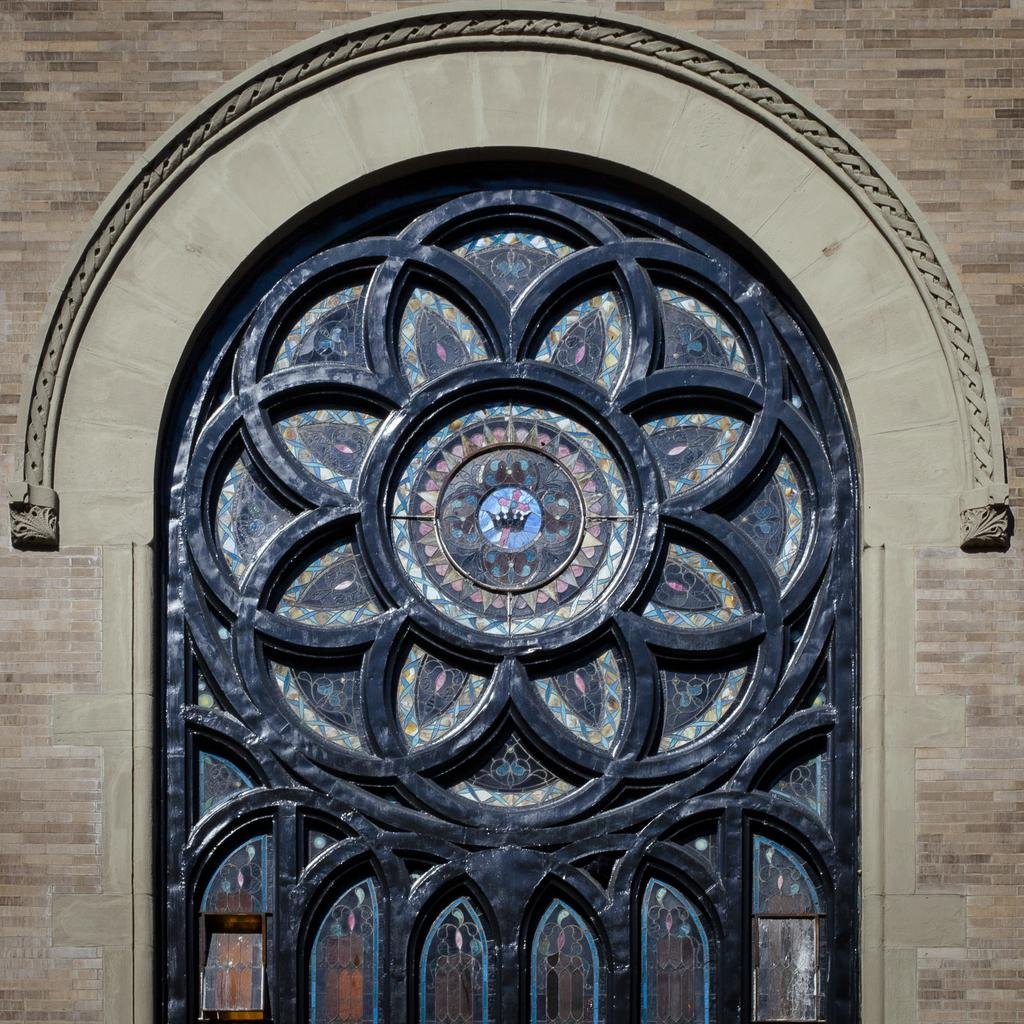What is present on the wall in the image? There is a wall in the image, and it has multiple glasses in the center and designs on it. Can you describe the designs on the wall? Unfortunately, the specific designs on the wall cannot be described with the information provided. Where are the glasses located on the wall? The glasses are located in the center of the wall. What type of lunchroom is visible in the image? There is no lunchroom present in the image; it only features a wall with multiple glasses and designs. Can you hear the ear in the image? There is no ear present in the image, so it cannot be heard or seen. 